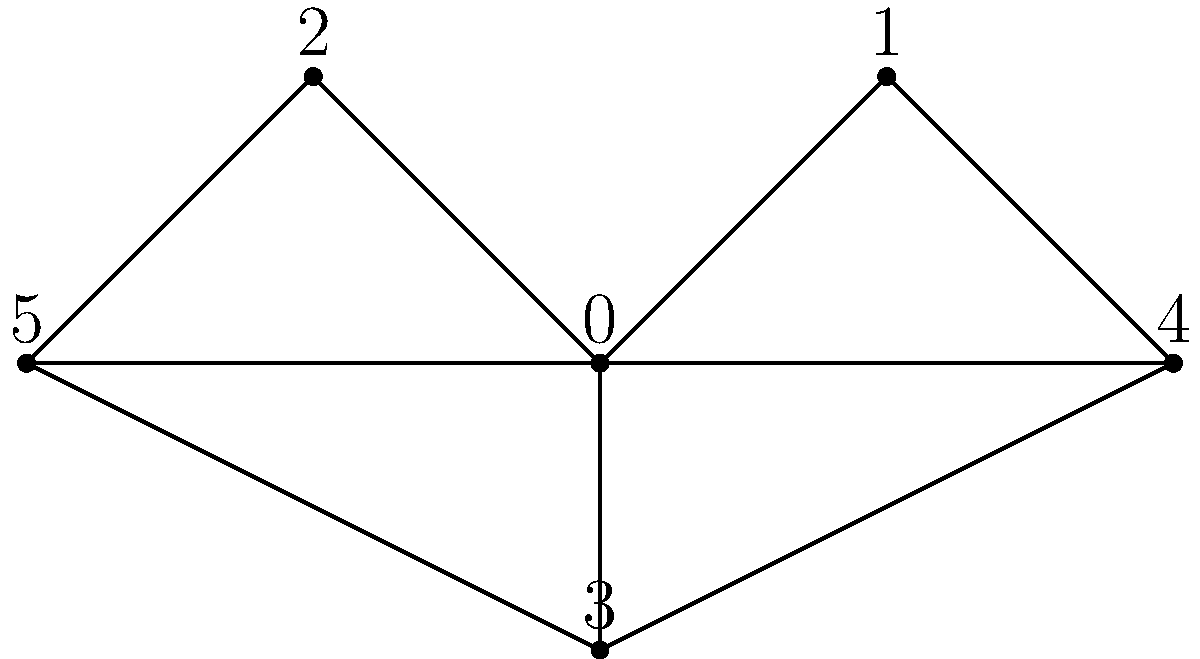As a songwriter looking to incorporate literary elements into your music, you've decided to analyze character relationships in a novel using a network graph. The bookshop owner suggests visualizing the connections between characters as shown in the graph above. If each node represents a character and each edge represents a significant interaction or relationship between characters, what is the degree of the character represented by node 0, and how might this information inspire your songwriting process? To answer this question, let's follow these steps:

1. Understand the concept of degree in graph theory:
   - The degree of a node is the number of edges connected to it.

2. Count the edges connected to node 0:
   - Node 0 is connected to nodes 1, 2, and 3.
   - There are 3 edges connected to node 0.

3. Determine the degree of node 0:
   - The degree of node 0 is 3.

4. Interpret this information for songwriting:
   - A high degree (3 in this case) indicates that this character has many interactions or relationships with other characters.
   - This could represent a central or influential character in the story.
   - In songwriting, you could:
     a) Focus on this character's perspective in your lyrics.
     b) Write about the impact this character has on others.
     c) Explore the complexity of managing multiple relationships.
     d) Use the number of connections as a metaphor for social influence or emotional burden.

5. Consider the overall structure:
   - The graph shows a interconnected network, which could inspire themes of community, interconnectedness, or the ripple effects of actions.

By visualizing character relationships this way, you can gain insights into the story's structure and character dynamics, which can inform your songwriting process and help you create lyrics that reflect the complexity of human relationships as portrayed in literature.
Answer: Degree of node 0 is 3; inspires themes of central character, multiple relationships, and interconnectedness in songwriting. 